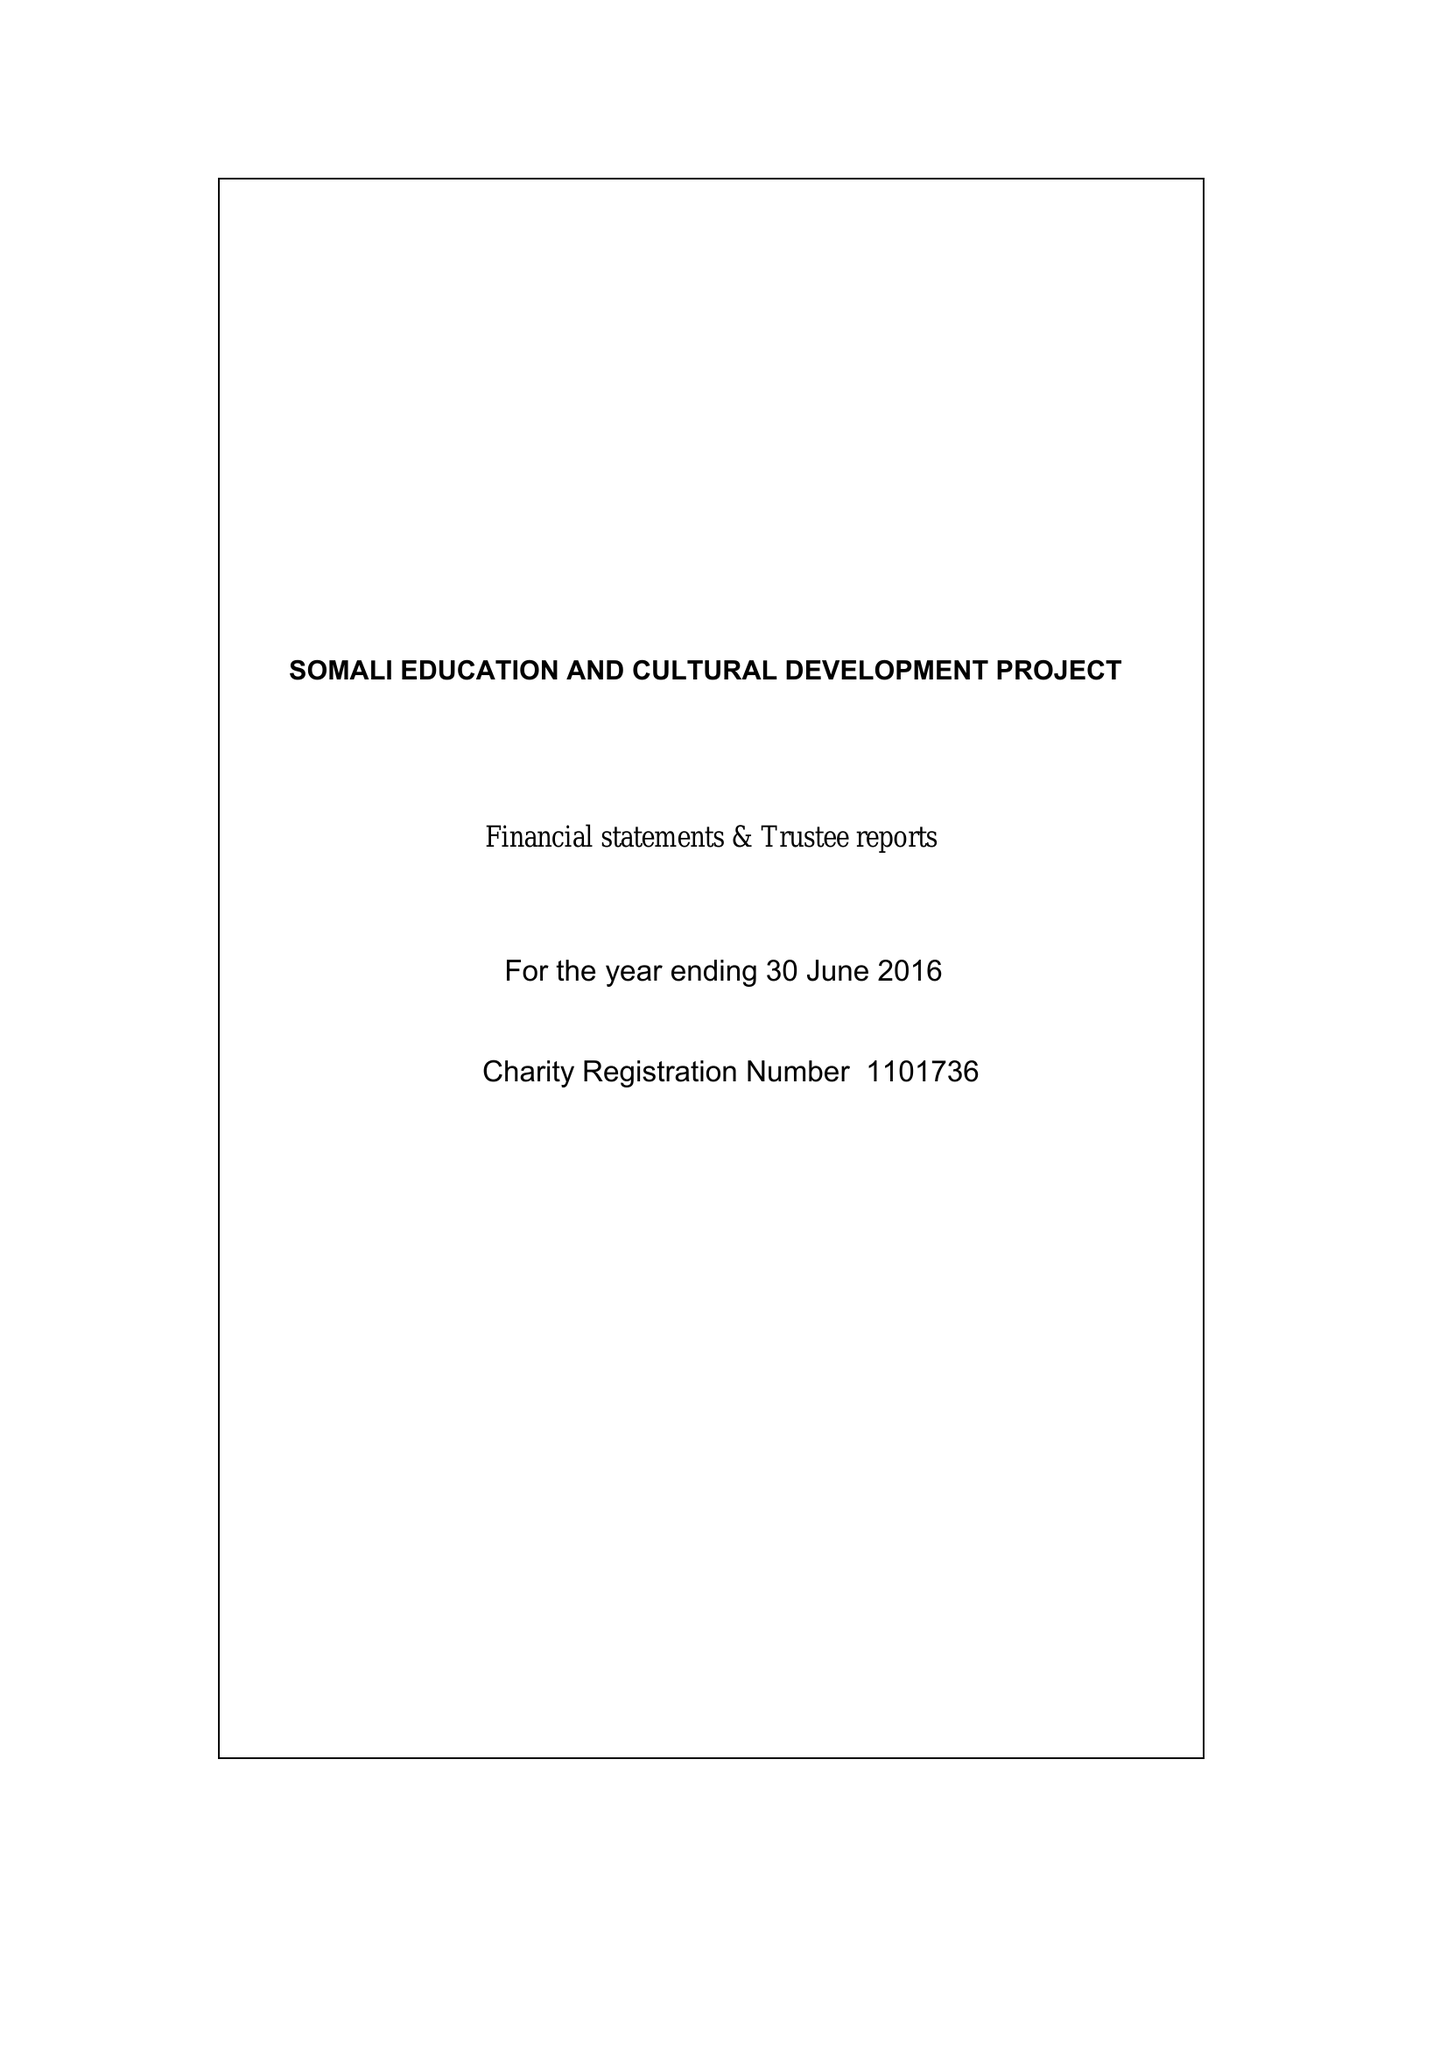What is the value for the report_date?
Answer the question using a single word or phrase. 2016-06-30 